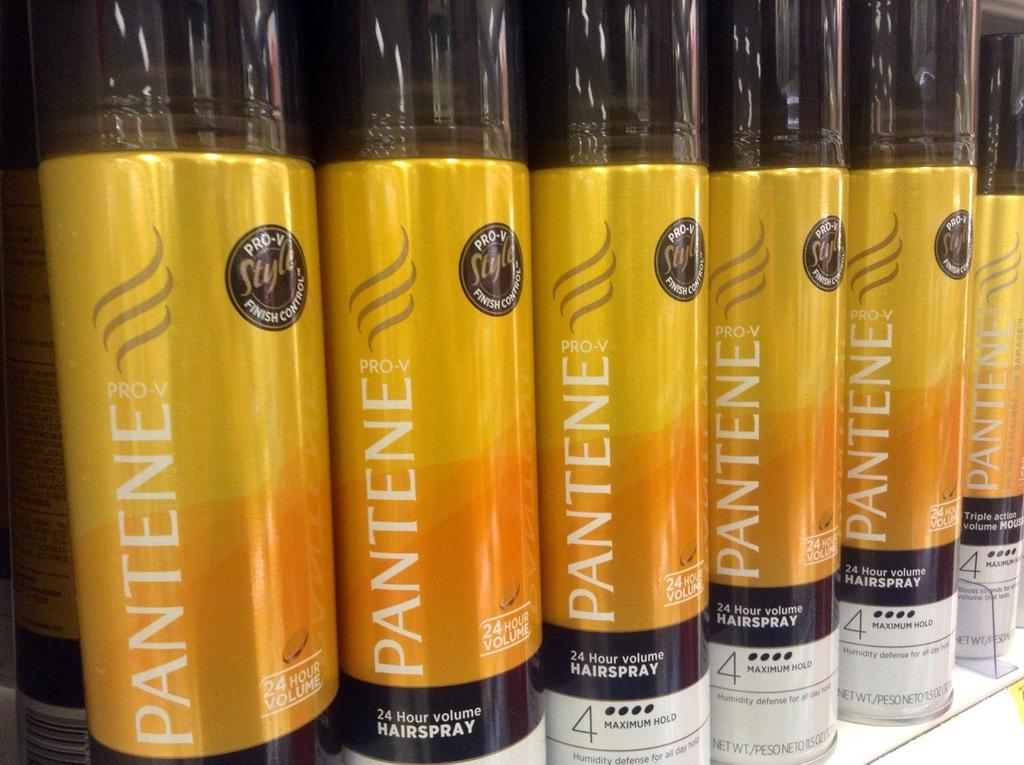<image>
Create a compact narrative representing the image presented. a few bottles that are yellow and say Pantene 